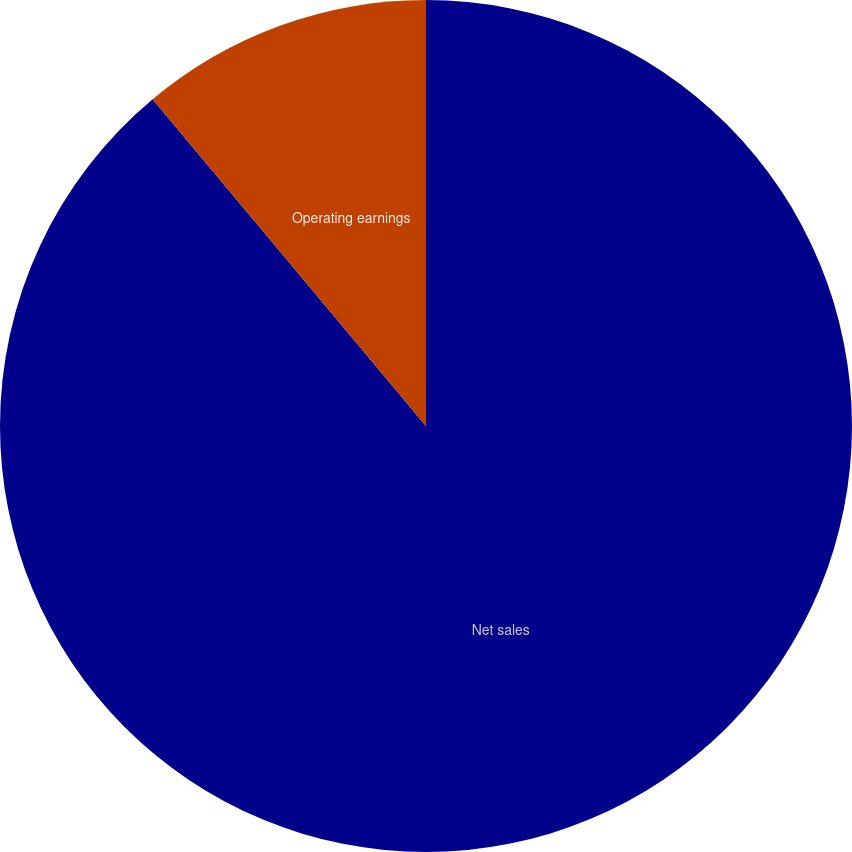<chart> <loc_0><loc_0><loc_500><loc_500><pie_chart><fcel>Net sales<fcel>Operating earnings<nl><fcel>88.91%<fcel>11.09%<nl></chart> 